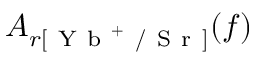<formula> <loc_0><loc_0><loc_500><loc_500>A _ { r [ Y b ^ { + } / S r ] } ( f )</formula> 